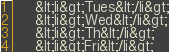<code> <loc_0><loc_0><loc_500><loc_500><_Ceylon_>     &lt;li&gt;Tues&lt;/li&gt;
     &lt;li&gt;Wed&lt;/li&gt;
     &lt;li&gt;Th&lt;/li&gt;
     &lt;li&gt;Fri&lt;/li&gt;</code> 